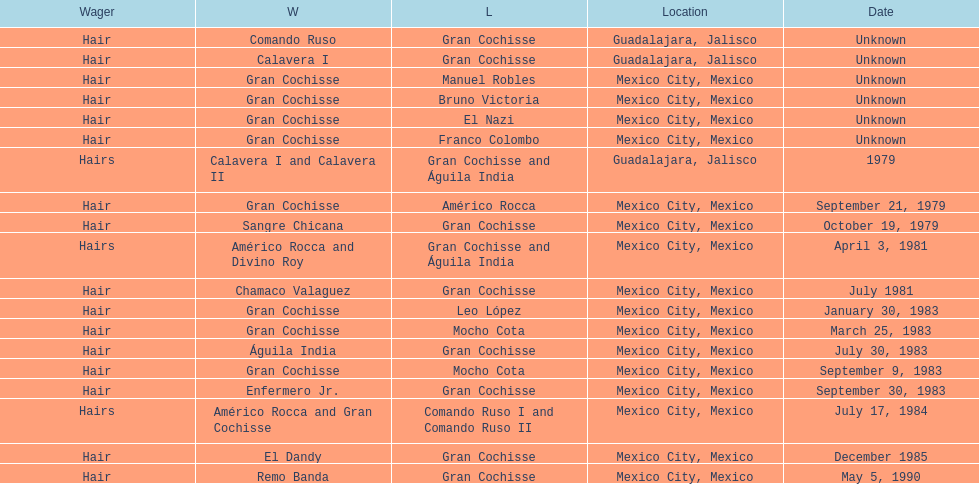When was gran chochisse's initial match with a complete date documented? September 21, 1979. 